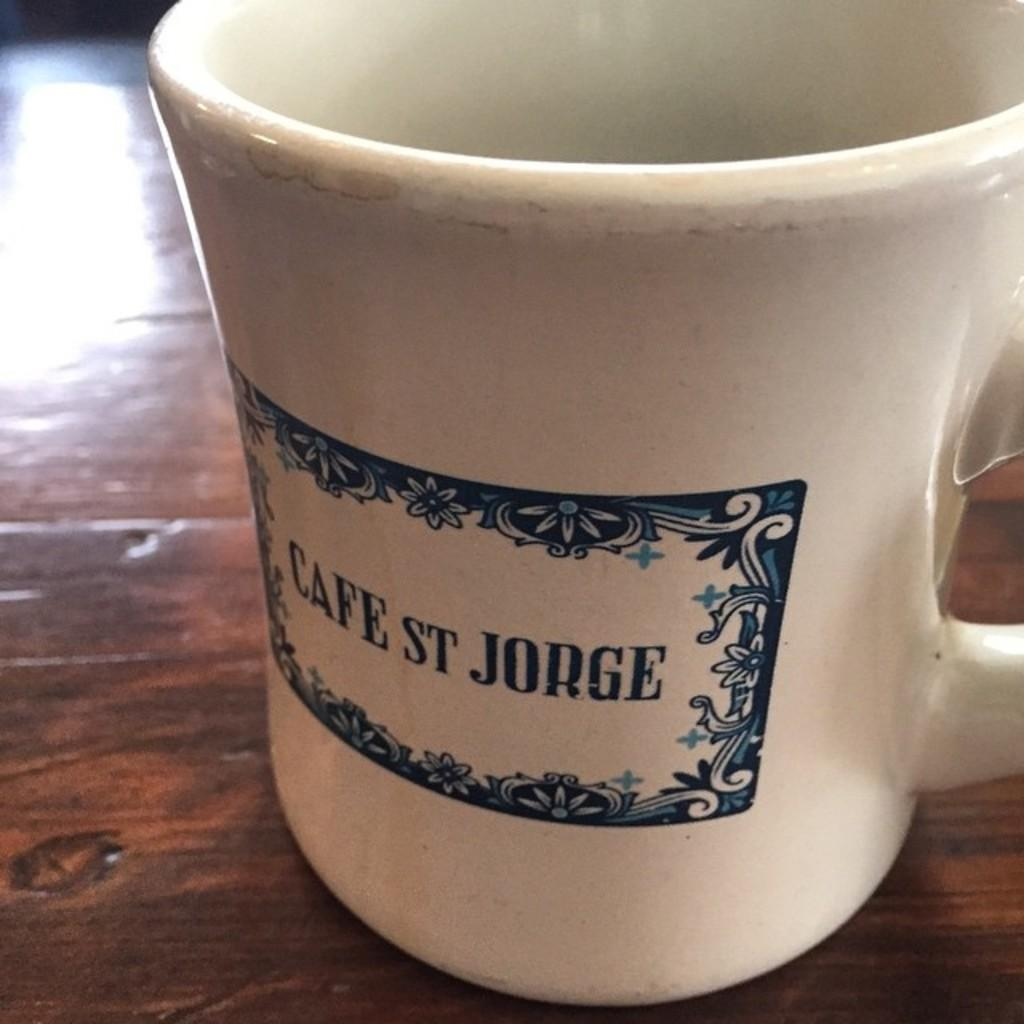<image>
Describe the image concisely. the word Jorge is on the white cup on the table 